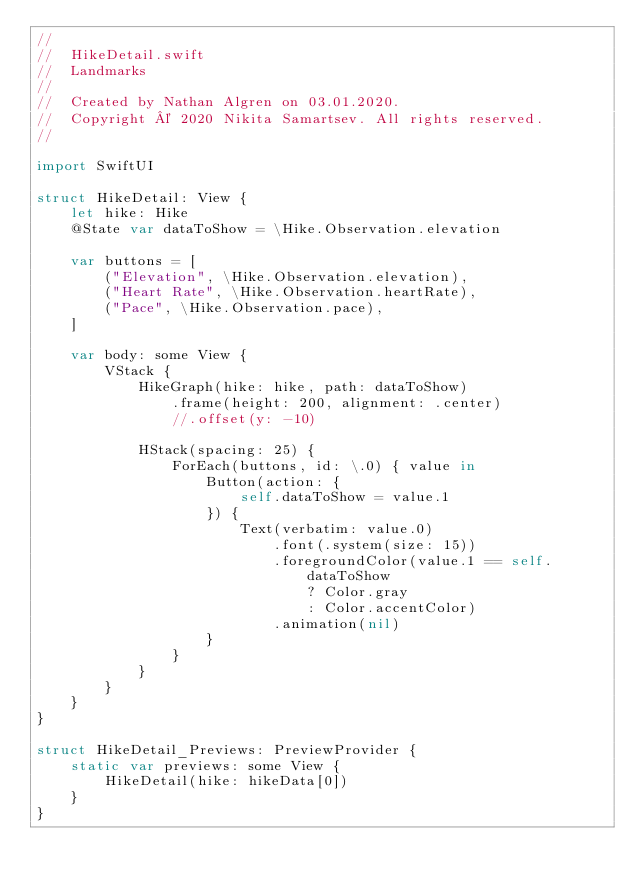<code> <loc_0><loc_0><loc_500><loc_500><_Swift_>//
//  HikeDetail.swift
//  Landmarks
//
//  Created by Nathan Algren on 03.01.2020.
//  Copyright © 2020 Nikita Samartsev. All rights reserved.
//

import SwiftUI

struct HikeDetail: View {
    let hike: Hike
    @State var dataToShow = \Hike.Observation.elevation
    
    var buttons = [
        ("Elevation", \Hike.Observation.elevation),
        ("Heart Rate", \Hike.Observation.heartRate),
        ("Pace", \Hike.Observation.pace),
    ]
    
    var body: some View {
        VStack {
            HikeGraph(hike: hike, path: dataToShow)
                .frame(height: 200, alignment: .center)
                //.offset(y: -10)
            
            HStack(spacing: 25) {
                ForEach(buttons, id: \.0) { value in
                    Button(action: {
                        self.dataToShow = value.1
                    }) {
                        Text(verbatim: value.0)
                            .font(.system(size: 15))
                            .foregroundColor(value.1 == self.dataToShow
                                ? Color.gray
                                : Color.accentColor)
                            .animation(nil)
                    }
                }
            }
        }
    }
}

struct HikeDetail_Previews: PreviewProvider {
    static var previews: some View {
        HikeDetail(hike: hikeData[0])
    }
}
</code> 